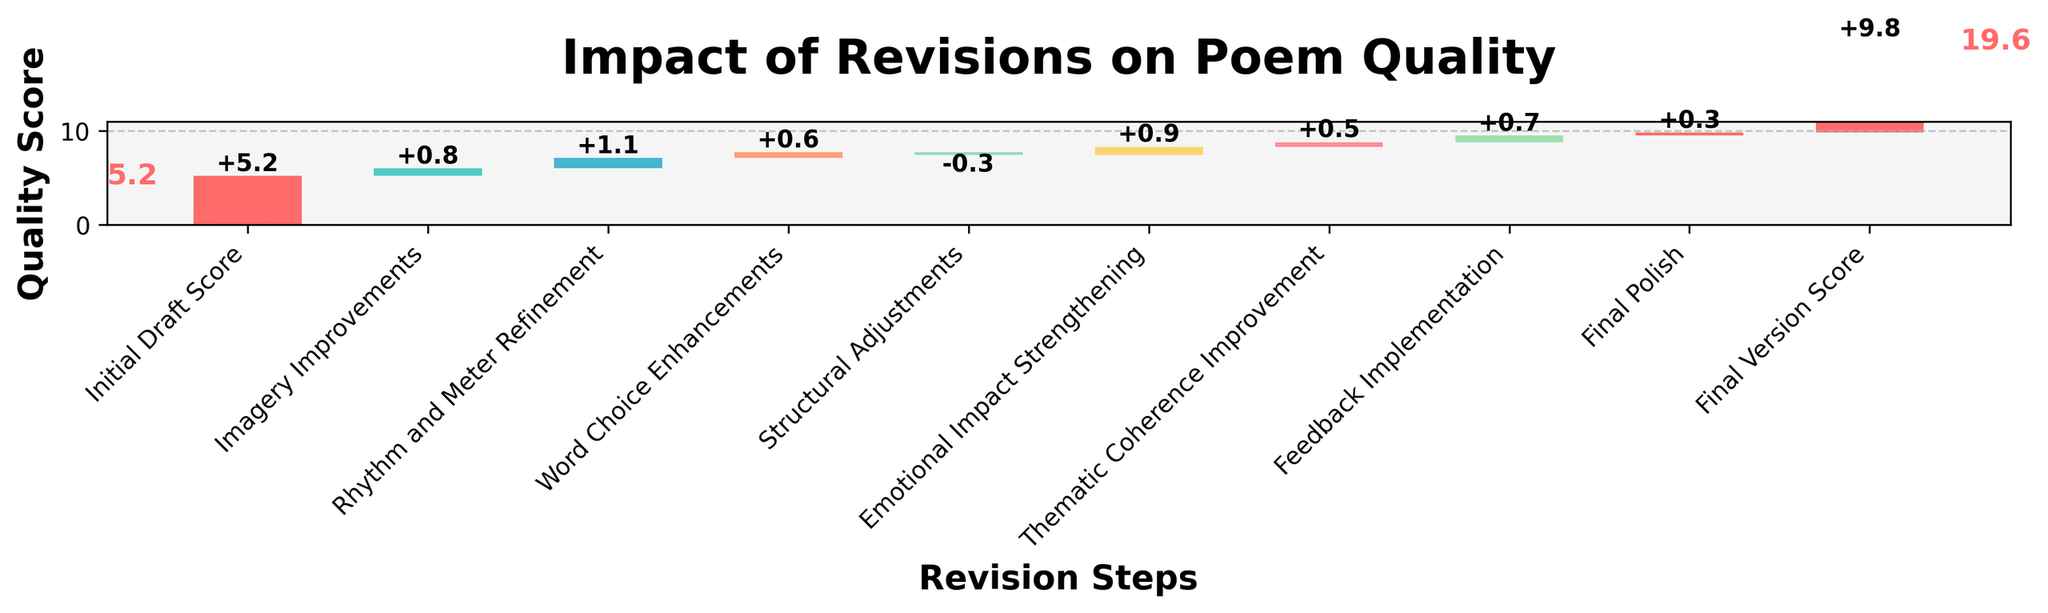What's the title of the chart? The title is usually located at the top of the chart. In this chart, it reads "Impact of Revisions on Poem Quality".
Answer: Impact of Revisions on Poem Quality How many revision steps are shown in the chart? There are nine categories listed under the x-axis, each representing a step in the revision process.
Answer: 9 What is the Initial Draft Score? The Initial Draft Score is the first bar on the left side of the chart. It shows a value of 5.2.
Answer: 5.2 What was the score after the Imagery Improvements step? The Imagery Improvements step added +0.8 to the Initial Draft Score of 5.2, resulting in a score of 6.0.
Answer: 6.0 What is the overall change in the poem quality score after all revisions? The final version score minus the initial draft score indicates the overall change. The final score is 9.8, and the initial score is 5.2. So the change is 9.8 - 5.2 = 4.6.
Answer: 4.6 Which revision step contributed the most to the quality score? To determine which step had the highest impact, look for the largest positive increment. The Rhythm and Meter Refinement step added +1.1, which is the highest positive value among all steps.
Answer: Rhythm and Meter Refinement At which step did the poem score decrease? The only step with a negative value is Structural Adjustments, which shows a value of -0.3.
Answer: Structural Adjustments By how much did the Emotional Impact Strengthening step improve the score? The Emotional Impact Strengthening step had a positive impact of +0.9 on the quality score.
Answer: +0.9 What is the cumulative score after the Feedback Implementation step? Sum the values up to and including the Feedback Implementation step. Initial Draft (5.2) + Imagery Improvements (+0.8) + Rhythm and Meter Refinement (+1.1) + Word Choice Enhancements (+0.6) + Structural Adjustments (-0.3) + Emotional Impact Strengthening (+0.9) + Thematic Coherence Improvement (+0.5) + Feedback Implementation (+0.7). The result is 9.5.
Answer: 9.5 